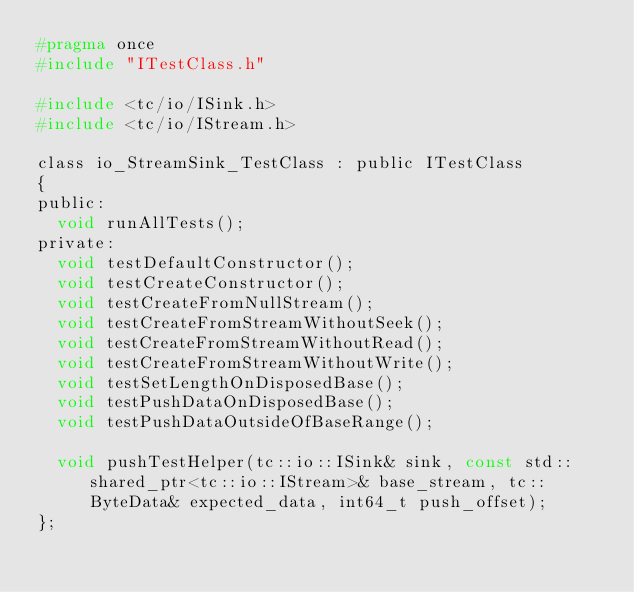<code> <loc_0><loc_0><loc_500><loc_500><_C_>#pragma once
#include "ITestClass.h"

#include <tc/io/ISink.h>
#include <tc/io/IStream.h>

class io_StreamSink_TestClass : public ITestClass
{
public:
	void runAllTests();
private:
	void testDefaultConstructor();
	void testCreateConstructor();
	void testCreateFromNullStream();
	void testCreateFromStreamWithoutSeek();
	void testCreateFromStreamWithoutRead();
	void testCreateFromStreamWithoutWrite();
	void testSetLengthOnDisposedBase();
	void testPushDataOnDisposedBase();
	void testPushDataOutsideOfBaseRange();

	void pushTestHelper(tc::io::ISink& sink, const std::shared_ptr<tc::io::IStream>& base_stream, tc::ByteData& expected_data, int64_t push_offset);
};
</code> 